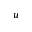Convert formula to latex. <formula><loc_0><loc_0><loc_500><loc_500>u</formula> 